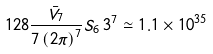Convert formula to latex. <formula><loc_0><loc_0><loc_500><loc_500>1 2 8 \frac { \bar { V } _ { 7 } } { 7 \left ( 2 \pi \right ) ^ { 7 } } S _ { 6 } \, 3 ^ { 7 } \simeq 1 . 1 \times 1 0 ^ { 3 5 }</formula> 